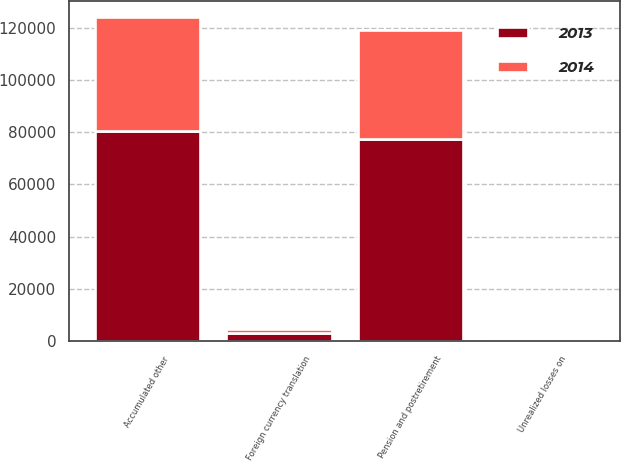Convert chart. <chart><loc_0><loc_0><loc_500><loc_500><stacked_bar_chart><ecel><fcel>Foreign currency translation<fcel>Unrealized losses on<fcel>Pension and postretirement<fcel>Accumulated other<nl><fcel>2013<fcel>3086<fcel>110<fcel>77318<fcel>80514<nl><fcel>2014<fcel>1800<fcel>75<fcel>41613<fcel>43488<nl></chart> 